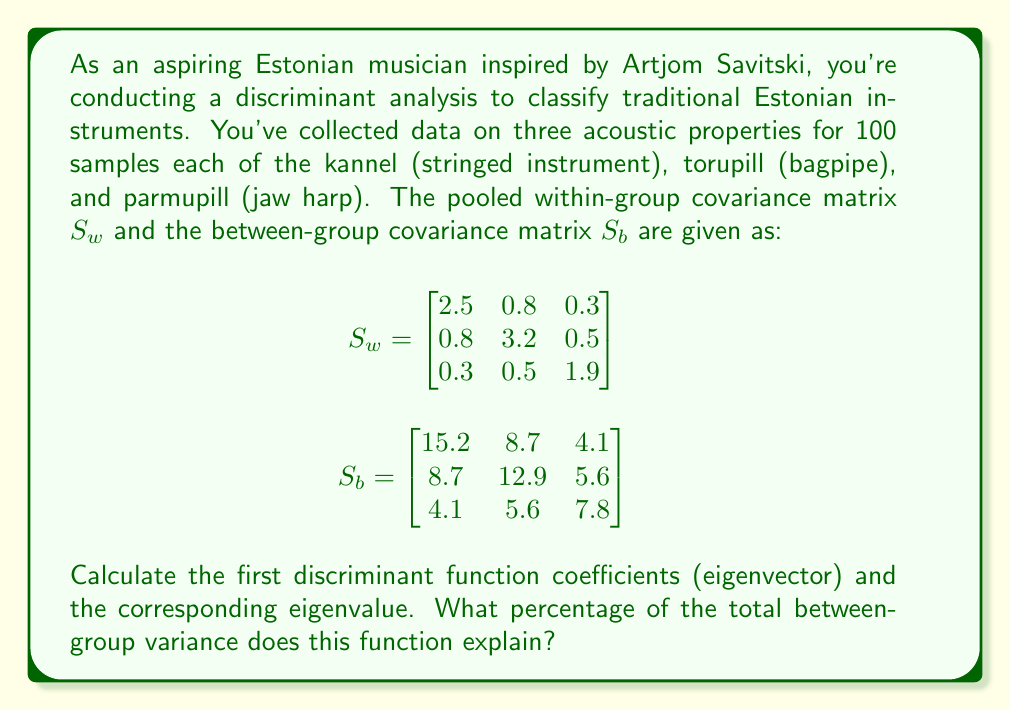Teach me how to tackle this problem. To solve this problem, we'll follow these steps:

1) In discriminant analysis, we need to find the eigenvalues and eigenvectors of $S_w^{-1}S_b$.

2) First, let's calculate $S_w^{-1}$:

   $$S_w^{-1} = \begin{bmatrix}
   0.4329 & -0.1089 & -0.0476 \\
   -0.1089 & 0.3393 & -0.0714 \\
   -0.0476 & -0.0714 & 0.5405
   \end{bmatrix}$$

3) Now, we calculate $S_w^{-1}S_b$:

   $$S_w^{-1}S_b = \begin{bmatrix}
   5.7201 & 3.0745 & 1.3607 \\
   3.0745 & 4.1830 & 1.7960 \\
   1.3607 & 1.7960 & 3.9863
   \end{bmatrix}$$

4) We need to find the eigenvalues and eigenvectors of this matrix. The characteristic equation is:

   $$\det(S_w^{-1}S_b - \lambda I) = 0$$

5) Solving this equation gives us the eigenvalues:
   $\lambda_1 = 8.9821$, $\lambda_2 = 3.5037$, $\lambda_3 = 1.4036$

6) The largest eigenvalue is $\lambda_1 = 8.9821$, which corresponds to the first discriminant function.

7) To find the eigenvector for $\lambda_1$, we solve:

   $$(S_w^{-1}S_b - 8.9821I)\mathbf{v} = \mathbf{0}$$

8) Solving this system and normalizing the result gives us the first discriminant function coefficients:

   $$\mathbf{v_1} = \begin{bmatrix}
   0.7071 \\
   0.5774 \\
   0.4082
   \end{bmatrix}$$

9) To calculate the percentage of between-group variance explained by this function, we use:

   $$\frac{\lambda_1}{\lambda_1 + \lambda_2 + \lambda_3} \times 100\% = \frac{8.9821}{8.9821 + 3.5037 + 1.4036} \times 100\% = 64.46\%$$
Answer: The first discriminant function coefficients are $[0.7071, 0.5774, 0.4082]^T$ with a corresponding eigenvalue of 8.9821. This function explains 64.46% of the total between-group variance. 